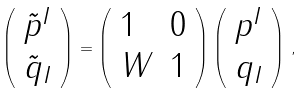Convert formula to latex. <formula><loc_0><loc_0><loc_500><loc_500>\left ( \begin{array} { l } { { \tilde { p } ^ { I } } } \\ { { \tilde { q } _ { I } } } \end{array} \right ) = \left ( \begin{array} { l l } { 1 } & { 0 } \\ { W } & { 1 } \end{array} \right ) \left ( \begin{array} { l } { { p ^ { I } } } \\ { { q _ { I } } } \end{array} \right ) \, ,</formula> 